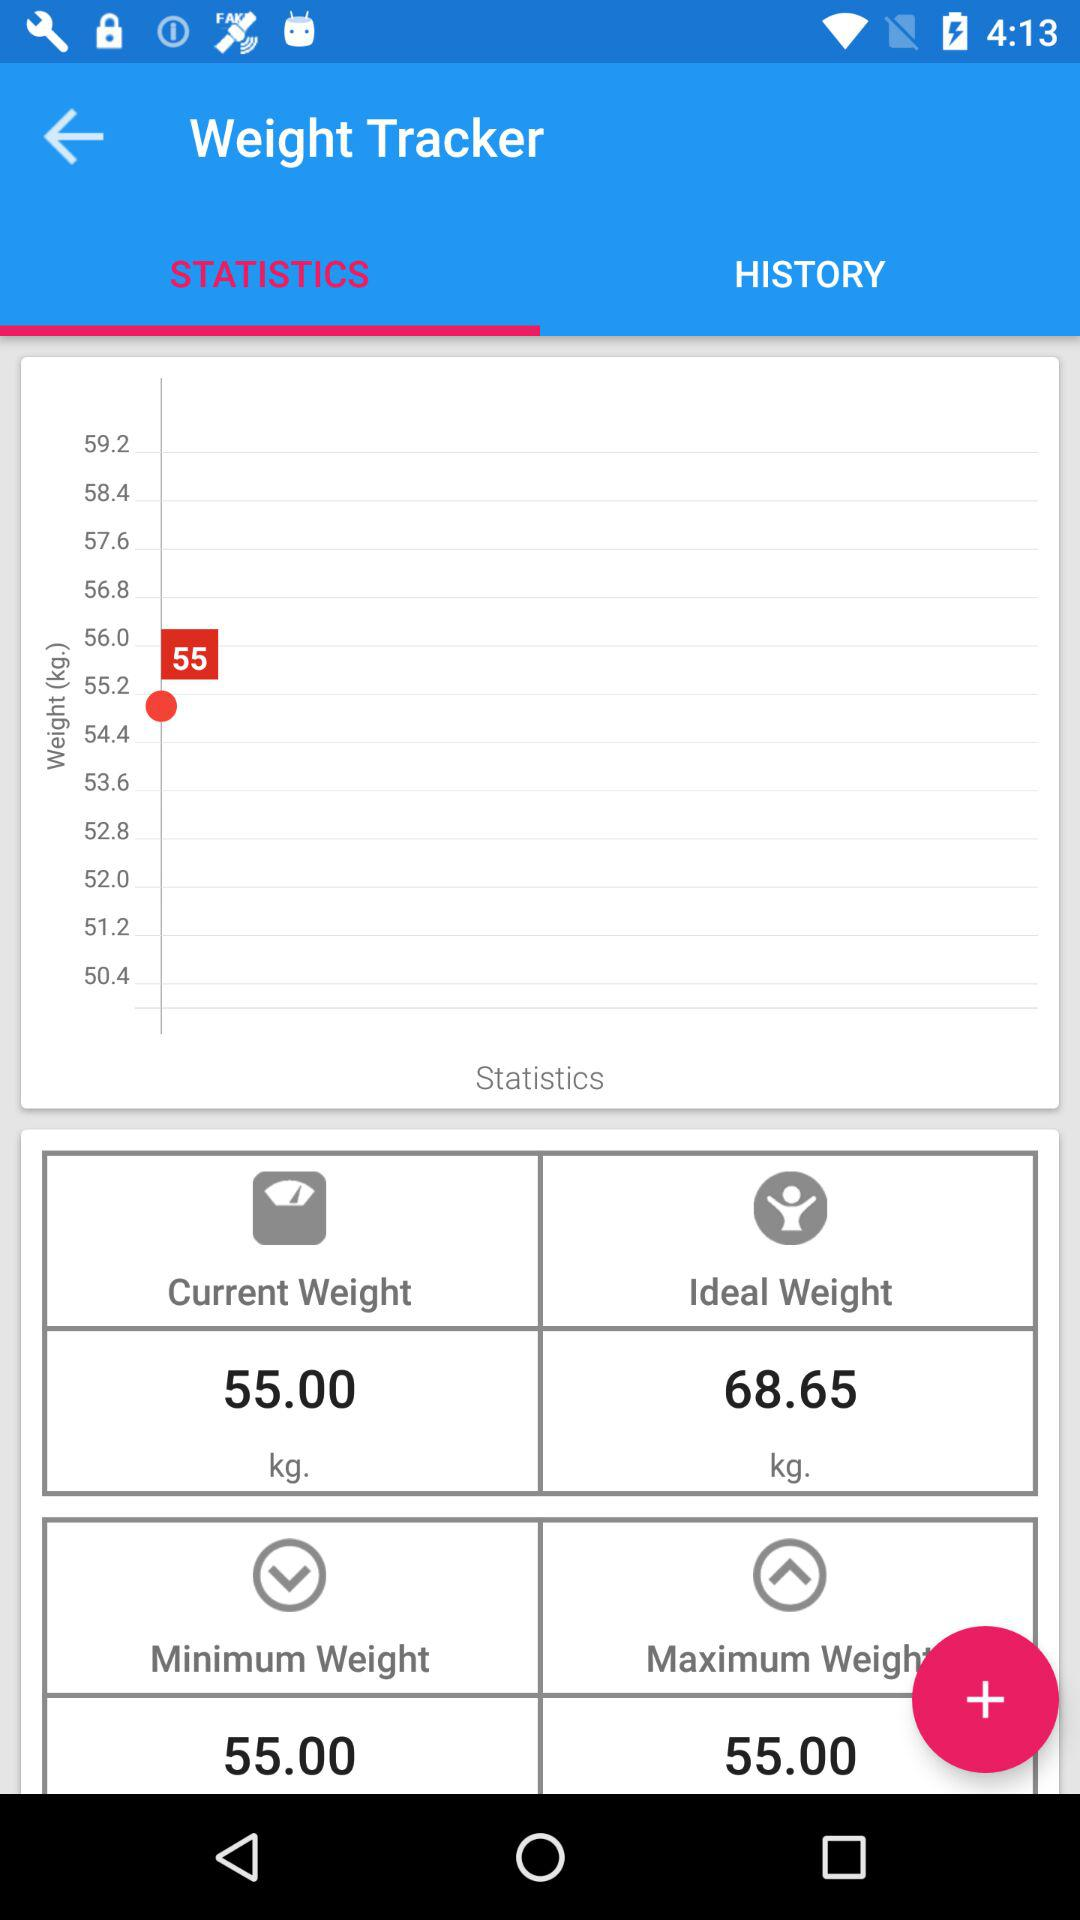What is the maximum weight? The maximum weight is 55 kg. 